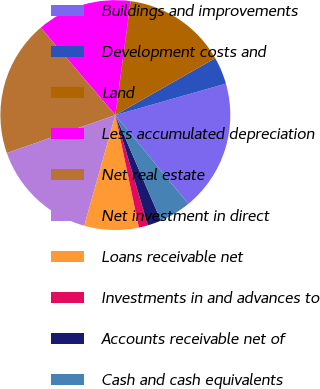<chart> <loc_0><loc_0><loc_500><loc_500><pie_chart><fcel>Buildings and improvements<fcel>Development costs and<fcel>Land<fcel>Less accumulated depreciation<fcel>Net real estate<fcel>Net investment in direct<fcel>Loans receivable net<fcel>Investments in and advances to<fcel>Accounts receivable net of<fcel>Cash and cash equivalents<nl><fcel>18.46%<fcel>3.83%<fcel>14.64%<fcel>13.37%<fcel>19.1%<fcel>15.28%<fcel>7.65%<fcel>1.28%<fcel>1.92%<fcel>4.46%<nl></chart> 